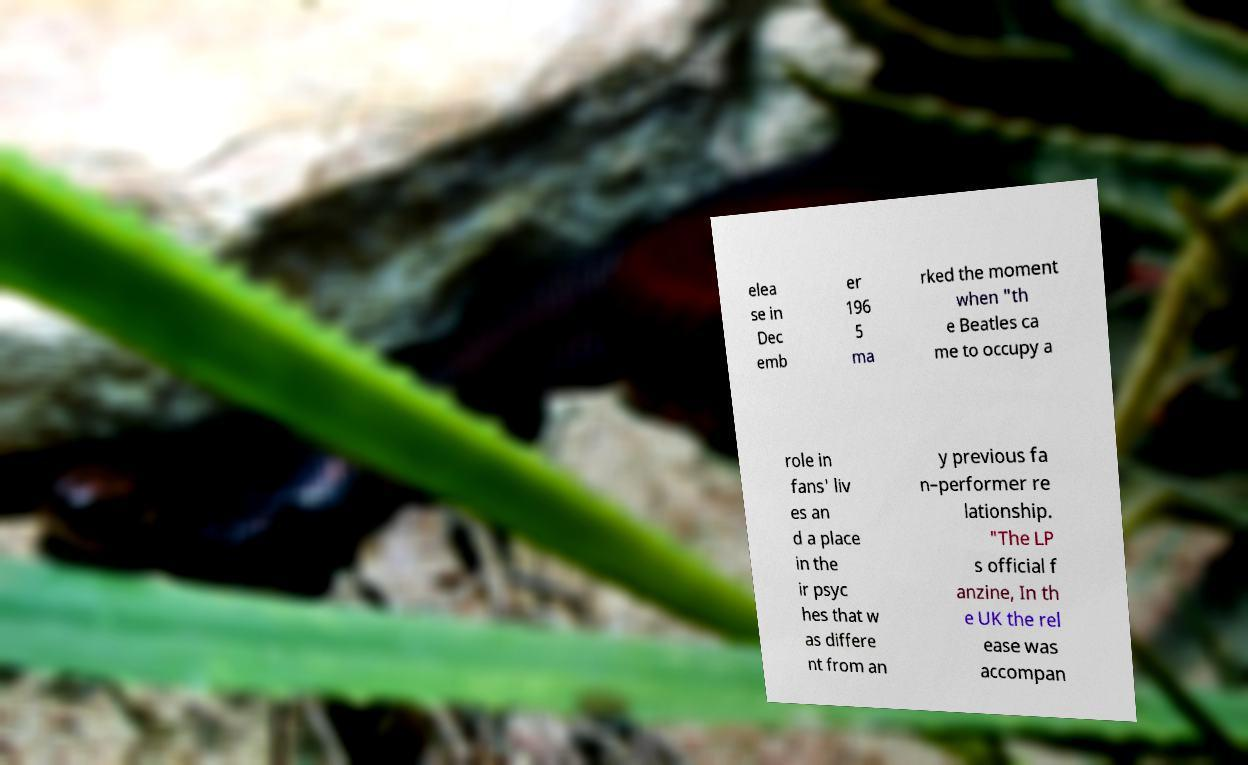Can you accurately transcribe the text from the provided image for me? elea se in Dec emb er 196 5 ma rked the moment when "th e Beatles ca me to occupy a role in fans' liv es an d a place in the ir psyc hes that w as differe nt from an y previous fa n–performer re lationship. "The LP s official f anzine, In th e UK the rel ease was accompan 